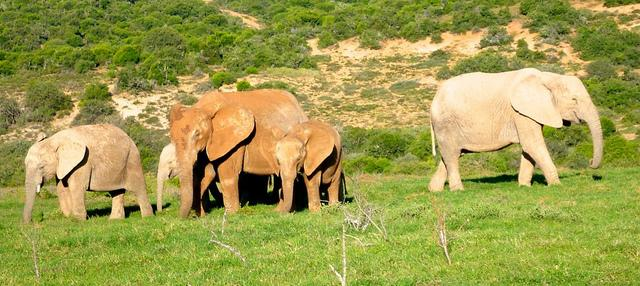What color is the skin of the dirty elephant in the middle? Please explain your reasoning. bronze. The dirt on the elephant is bronze colored. 